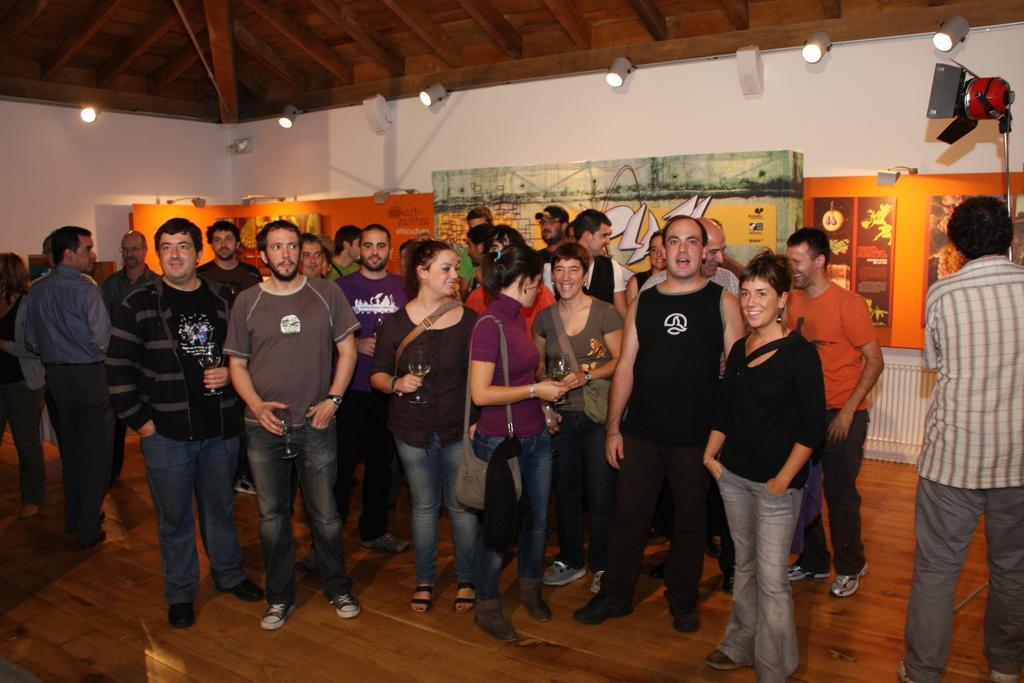Could you give a brief overview of what you see in this image? In the center of the image we can see a few people are standing and they are in different costumes. Among them, we can see a few people are smiling, few people are wearing backpacks and a few people are holding some objects. In the background there is a wall, roof, lights, boards with some text and a few other objects. 